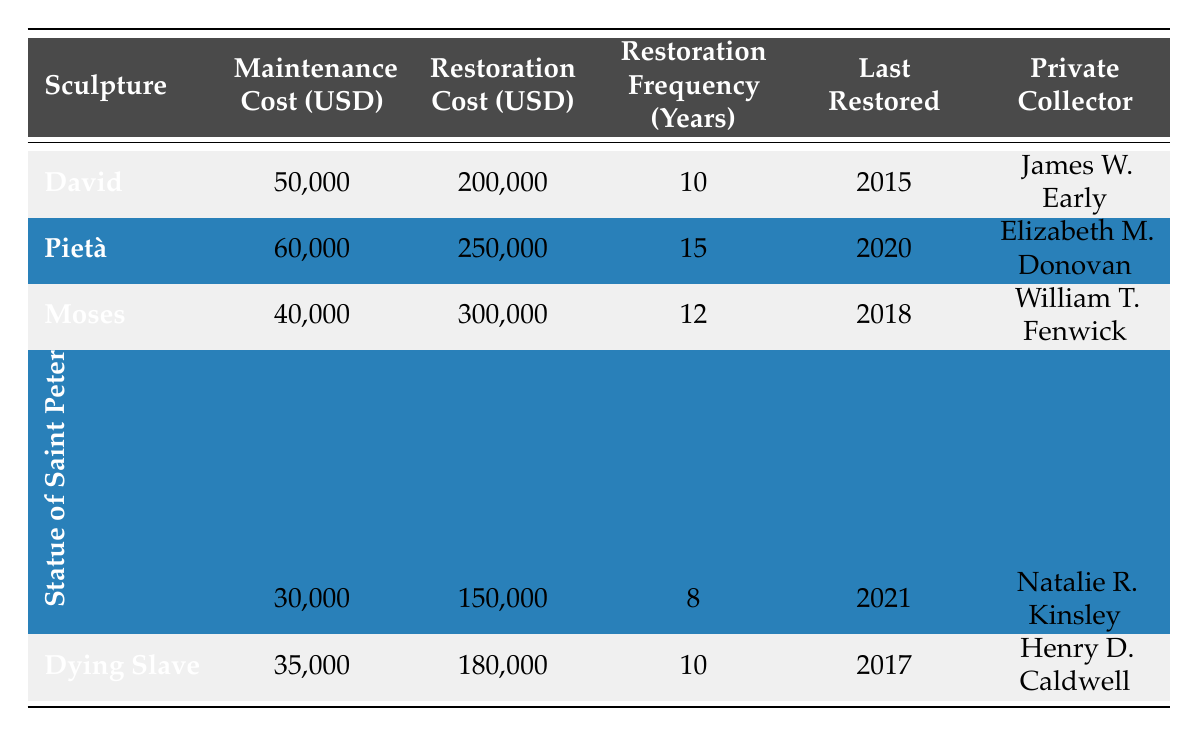What is the maintenance cost for the Pietà? The table states that the maintenance cost for the Pietà is listed under the relevant column, which shows 60,000 USD.
Answer: 60,000 USD How much is the restoration cost for the Statue of Saint Peter? According to the table, the restoration cost for the Statue of Saint Peter is directly stated as 150,000 USD.
Answer: 150,000 USD What is the average maintenance cost of all the sculptures? To calculate the average, sum the maintenance costs (50,000 + 60,000 + 40,000 + 30,000 + 35,000 = 215,000) and divide by the number of sculptures (5). The average maintenance cost is 215,000 / 5 = 43,000 USD.
Answer: 43,000 USD When was the last restoration for Moses? The table specifies that the last restoration year for Moses is 2018, which can be found in the corresponding column.
Answer: 2018 Is the restoration frequency for the Dying Slave greater than for the Pietà? The Dying Slave has a restoration frequency of 10 years, while the Pietà has a frequency of 15 years. Thus, it is false that the Dying Slave's frequency is greater; it is actually lower.
Answer: No Which sculpture has the highest restoration cost, and what is that cost? By examining the restoration costs, Moses has the highest cost at 300,000 USD, based on the numbers listed in that column.
Answer: Moses, 300,000 USD How many sculptures were restored last in or after 2020? The relevant years are 2020 and 2021. Checking the last restoration years, both the Pietà (2020) and the Statue of Saint Peter (2021) fall into this range. Thus, there are two sculptures restored in or after 2020.
Answer: 2 What is the total maintenance cost for all sculptures? The total is found by summing all maintenance costs: (50,000 + 60,000 + 40,000 + 30,000 + 35,000 = 215,000 USD).
Answer: 215,000 USD What conservation methods are recommended for the Moses sculpture? The table lists the recommended conservation methods for Moses as "Structural support" and "Surface cleaning," which are identified in the respective column.
Answer: Structural support, Surface cleaning If the restoration for the David sculpture is done next in 2025, how many years will have passed since its last restoration? The last restoration year for David is 2015. If the next is in 2025, that is 2025 - 2015 = 10 years since the last restoration.
Answer: 10 years 